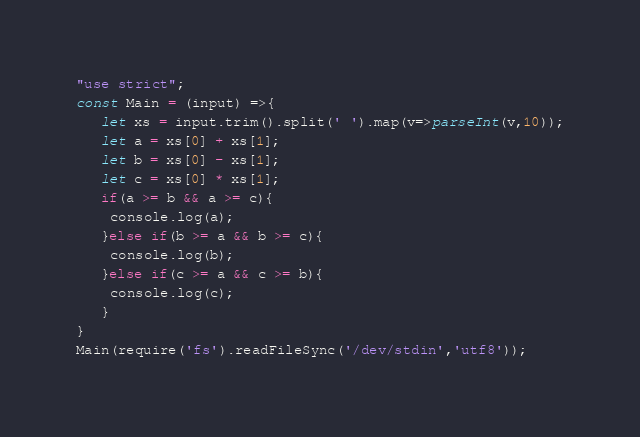Convert code to text. <code><loc_0><loc_0><loc_500><loc_500><_JavaScript_>"use strict";
const Main = (input) =>{
   let xs = input.trim().split(' ').map(v=>parseInt(v,10));
   let a = xs[0] + xs[1];
   let b = xs[0] - xs[1];
   let c = xs[0] * xs[1];
   if(a >= b && a >= c){
    console.log(a);
   }else if(b >= a && b >= c){
    console.log(b);
   }else if(c >= a && c >= b){
    console.log(c);        
   }
}
Main(require('fs').readFileSync('/dev/stdin','utf8'));</code> 